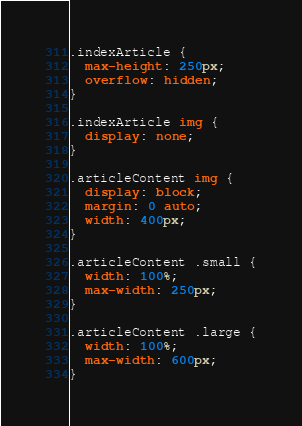Convert code to text. <code><loc_0><loc_0><loc_500><loc_500><_CSS_>.indexArticle {
  max-height: 250px;
  overflow: hidden;
}

.indexArticle img {
  display: none;
}

.articleContent img {
  display: block;
  margin: 0 auto;
  width: 400px;
}

.articleContent .small {
  width: 100%;
  max-width: 250px;
}

.articleContent .large {
  width: 100%;
  max-width: 600px;
}
</code> 